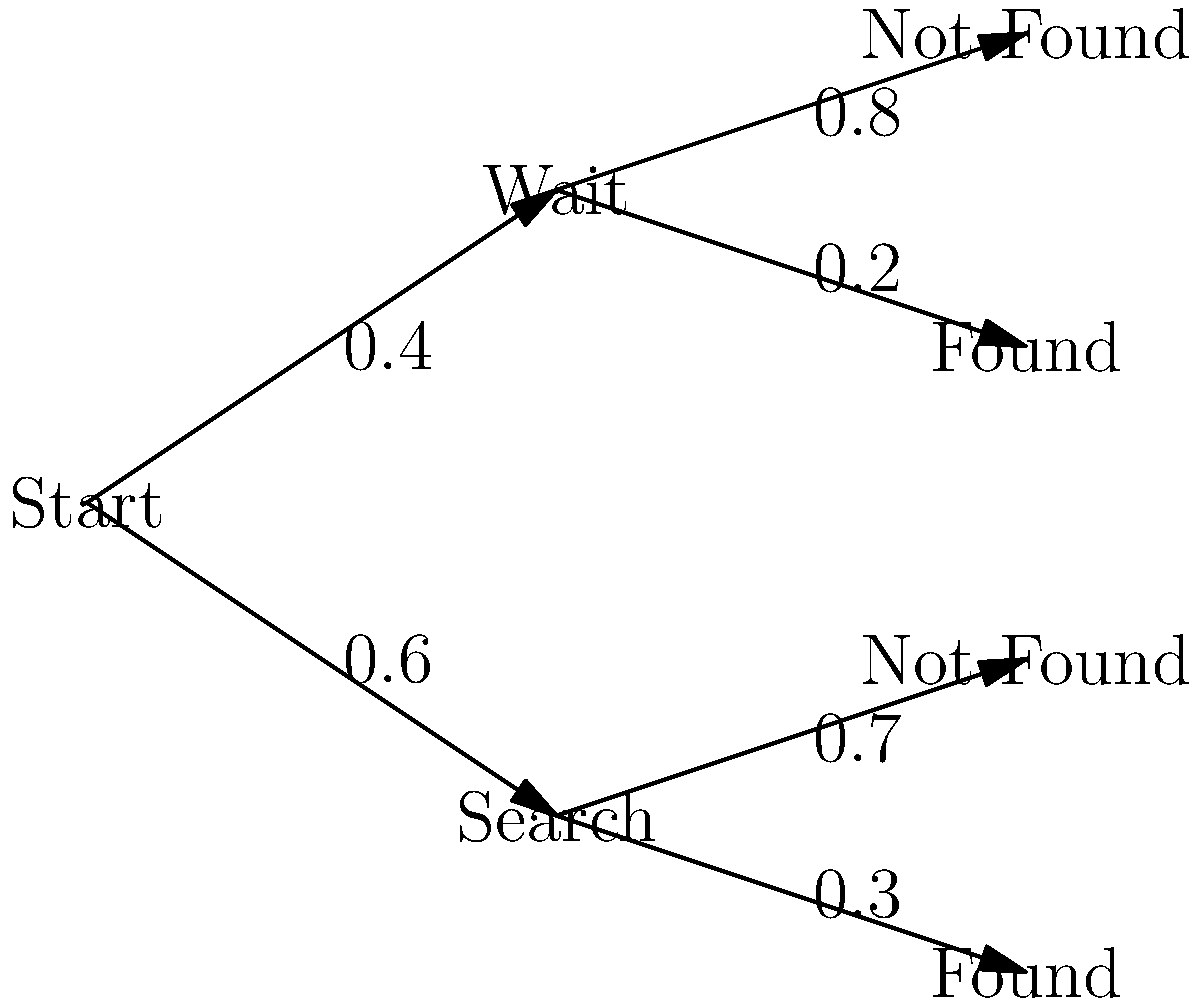Given the decision tree diagram above, which represents the probability of reuniting with a separated family member after a natural disaster, calculate the overall probability of finding the family member. To calculate the overall probability of finding the family member, we need to sum up the probabilities of all paths that lead to a "Found" outcome:

1. Path 1: Start → Search → Found
   Probability = $0.6 \times 0.3 = 0.18$

2. Path 2: Start → Wait → Found
   Probability = $0.4 \times 0.2 = 0.08$

3. Total probability of finding the family member:
   $P(\text{Found}) = 0.18 + 0.08 = 0.26$

Therefore, the overall probability of finding the separated family member is 0.26 or 26%.
Answer: 0.26 